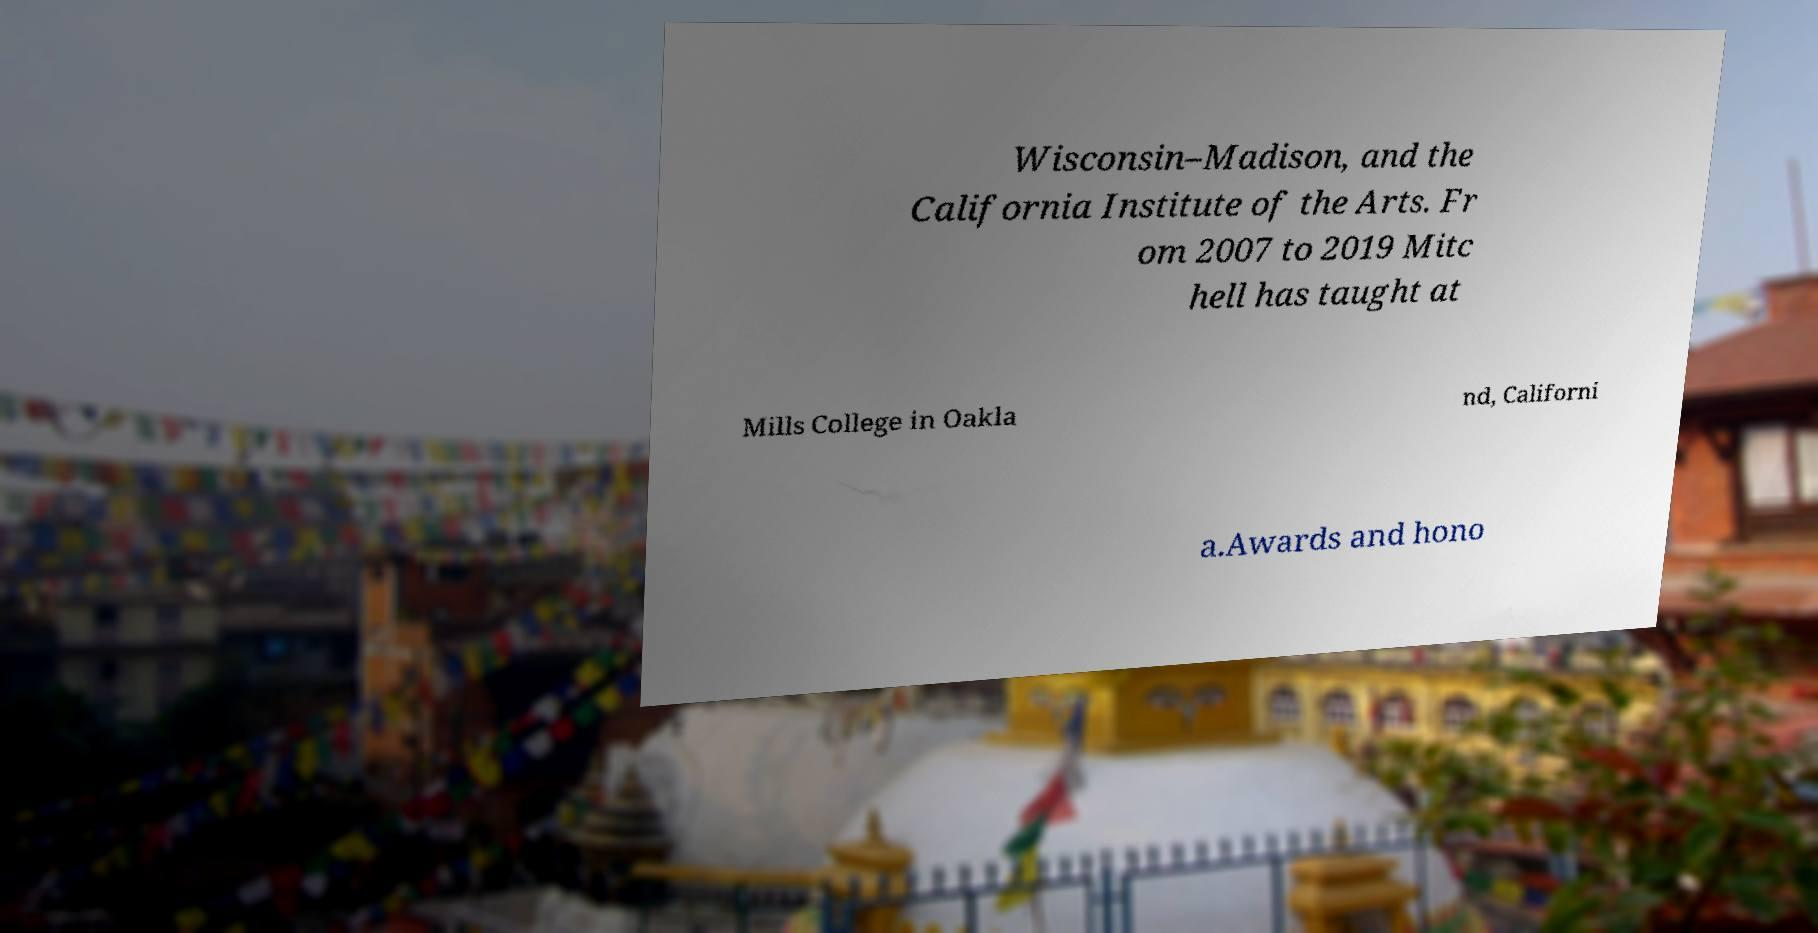For documentation purposes, I need the text within this image transcribed. Could you provide that? Wisconsin–Madison, and the California Institute of the Arts. Fr om 2007 to 2019 Mitc hell has taught at Mills College in Oakla nd, Californi a.Awards and hono 